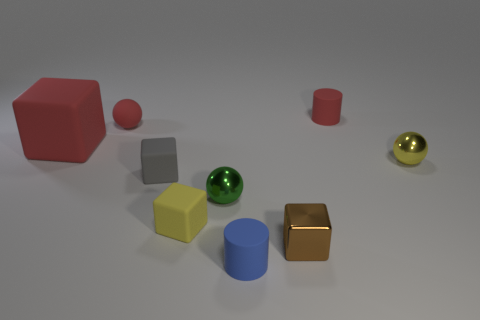Subtract 1 cubes. How many cubes are left? 3 Subtract all yellow cubes. How many cubes are left? 3 Subtract all small cubes. How many cubes are left? 1 Add 1 tiny red balls. How many objects exist? 10 Subtract all cyan spheres. Subtract all blue cylinders. How many spheres are left? 3 Subtract all cubes. How many objects are left? 5 Add 5 tiny gray rubber blocks. How many tiny gray rubber blocks are left? 6 Add 6 big red rubber cylinders. How many big red rubber cylinders exist? 6 Subtract 1 green balls. How many objects are left? 8 Subtract all red balls. Subtract all big gray matte cubes. How many objects are left? 8 